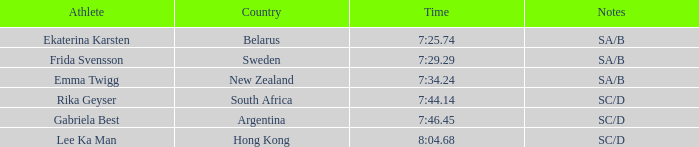What is the race time for emma twigg? 7:34.24. 